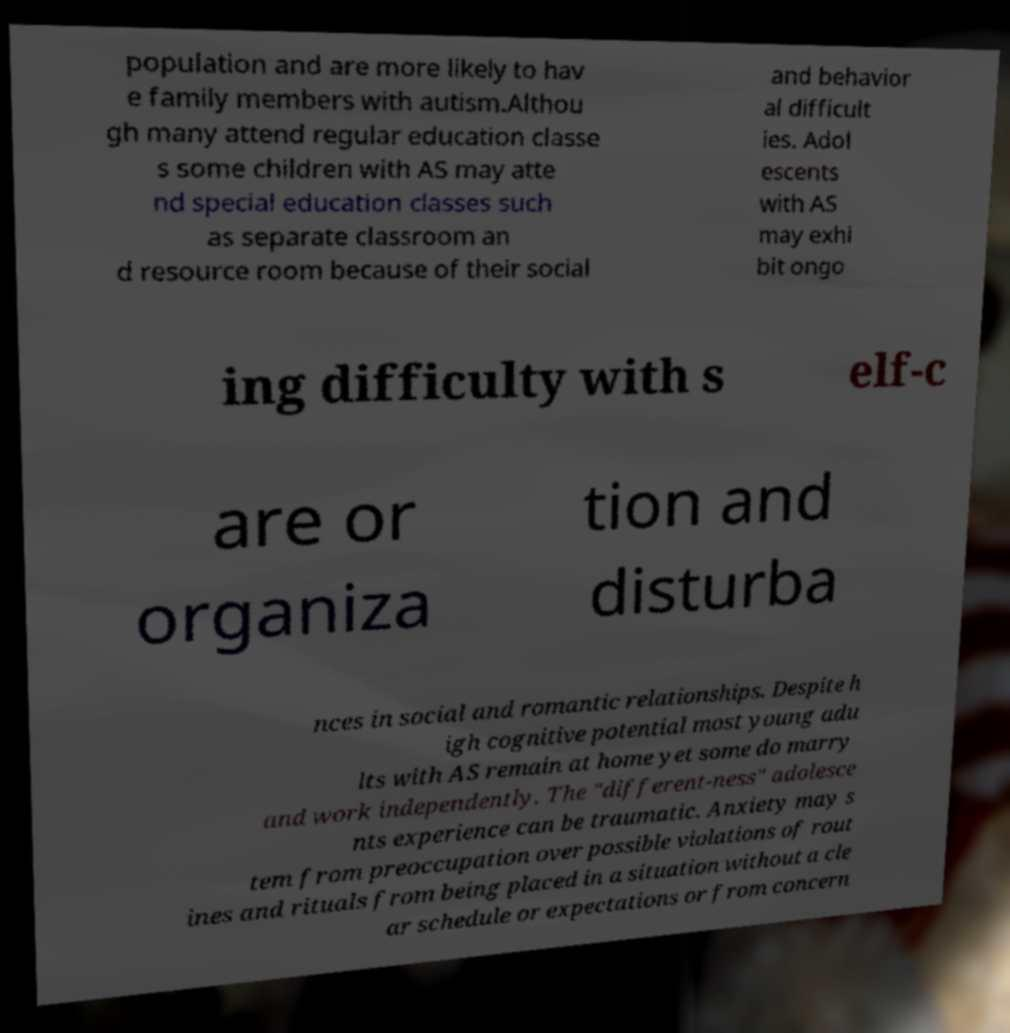I need the written content from this picture converted into text. Can you do that? population and are more likely to hav e family members with autism.Althou gh many attend regular education classe s some children with AS may atte nd special education classes such as separate classroom an d resource room because of their social and behavior al difficult ies. Adol escents with AS may exhi bit ongo ing difficulty with s elf-c are or organiza tion and disturba nces in social and romantic relationships. Despite h igh cognitive potential most young adu lts with AS remain at home yet some do marry and work independently. The "different-ness" adolesce nts experience can be traumatic. Anxiety may s tem from preoccupation over possible violations of rout ines and rituals from being placed in a situation without a cle ar schedule or expectations or from concern 